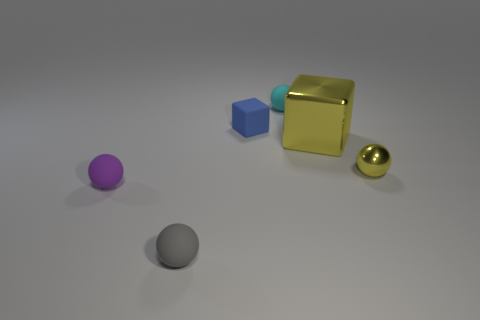Subtract all cyan matte spheres. How many spheres are left? 3 Add 1 small purple objects. How many objects exist? 7 Subtract 2 balls. How many balls are left? 2 Subtract all spheres. How many objects are left? 2 Subtract all cyan balls. How many balls are left? 3 Subtract all big blue shiny cubes. Subtract all small blue rubber things. How many objects are left? 5 Add 1 cyan spheres. How many cyan spheres are left? 2 Add 4 small cyan balls. How many small cyan balls exist? 5 Subtract 1 yellow balls. How many objects are left? 5 Subtract all red blocks. Subtract all gray cylinders. How many blocks are left? 2 